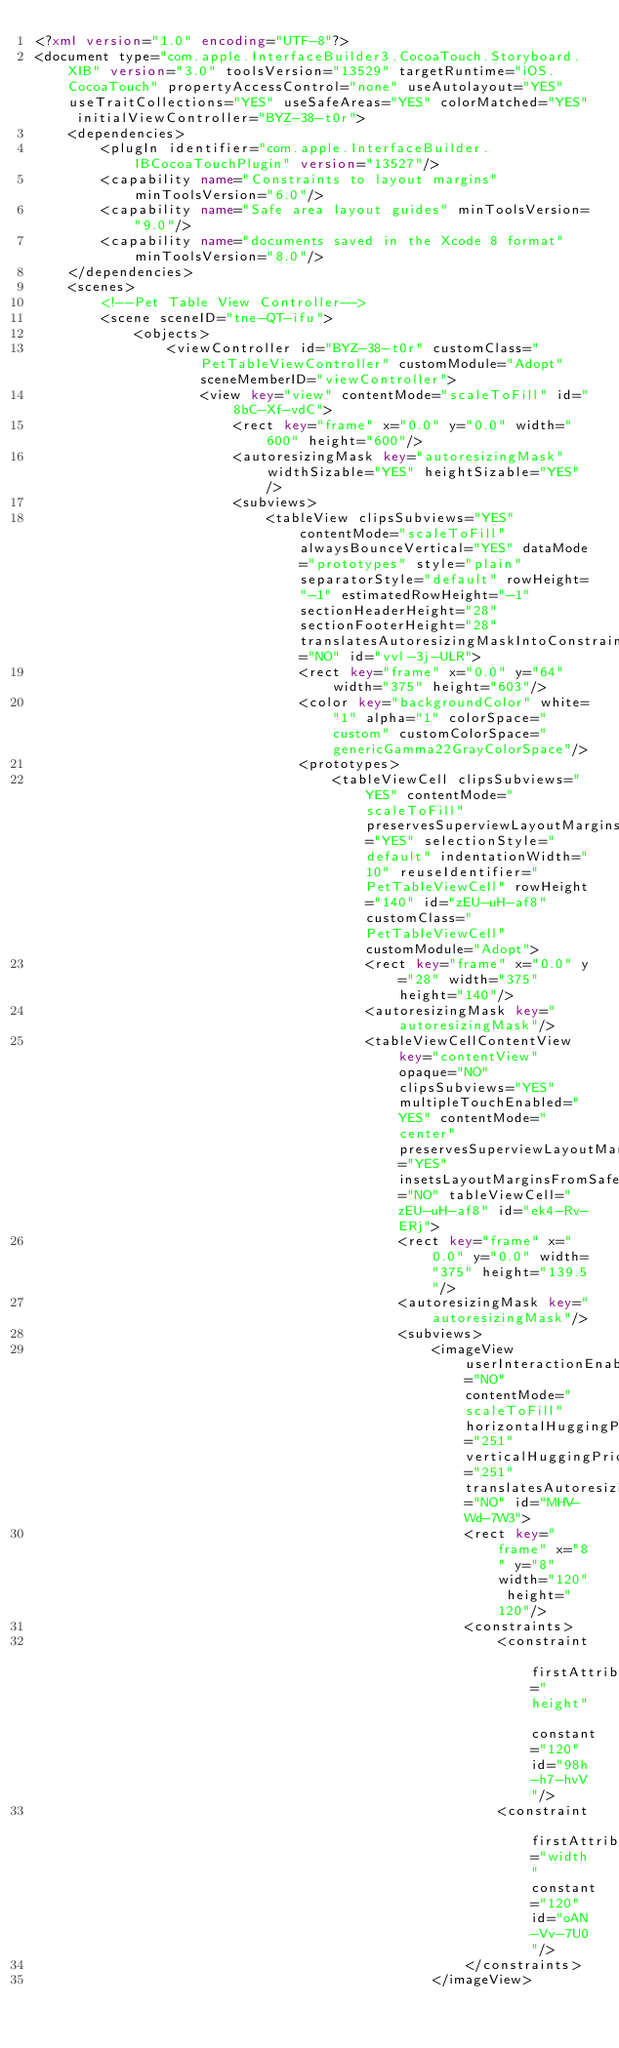<code> <loc_0><loc_0><loc_500><loc_500><_XML_><?xml version="1.0" encoding="UTF-8"?>
<document type="com.apple.InterfaceBuilder3.CocoaTouch.Storyboard.XIB" version="3.0" toolsVersion="13529" targetRuntime="iOS.CocoaTouch" propertyAccessControl="none" useAutolayout="YES" useTraitCollections="YES" useSafeAreas="YES" colorMatched="YES" initialViewController="BYZ-38-t0r">
    <dependencies>
        <plugIn identifier="com.apple.InterfaceBuilder.IBCocoaTouchPlugin" version="13527"/>
        <capability name="Constraints to layout margins" minToolsVersion="6.0"/>
        <capability name="Safe area layout guides" minToolsVersion="9.0"/>
        <capability name="documents saved in the Xcode 8 format" minToolsVersion="8.0"/>
    </dependencies>
    <scenes>
        <!--Pet Table View Controller-->
        <scene sceneID="tne-QT-ifu">
            <objects>
                <viewController id="BYZ-38-t0r" customClass="PetTableViewController" customModule="Adopt" sceneMemberID="viewController">
                    <view key="view" contentMode="scaleToFill" id="8bC-Xf-vdC">
                        <rect key="frame" x="0.0" y="0.0" width="600" height="600"/>
                        <autoresizingMask key="autoresizingMask" widthSizable="YES" heightSizable="YES"/>
                        <subviews>
                            <tableView clipsSubviews="YES" contentMode="scaleToFill" alwaysBounceVertical="YES" dataMode="prototypes" style="plain" separatorStyle="default" rowHeight="-1" estimatedRowHeight="-1" sectionHeaderHeight="28" sectionFooterHeight="28" translatesAutoresizingMaskIntoConstraints="NO" id="vvl-3j-ULR">
                                <rect key="frame" x="0.0" y="64" width="375" height="603"/>
                                <color key="backgroundColor" white="1" alpha="1" colorSpace="custom" customColorSpace="genericGamma22GrayColorSpace"/>
                                <prototypes>
                                    <tableViewCell clipsSubviews="YES" contentMode="scaleToFill" preservesSuperviewLayoutMargins="YES" selectionStyle="default" indentationWidth="10" reuseIdentifier="PetTableViewCell" rowHeight="140" id="zEU-uH-af8" customClass="PetTableViewCell" customModule="Adopt">
                                        <rect key="frame" x="0.0" y="28" width="375" height="140"/>
                                        <autoresizingMask key="autoresizingMask"/>
                                        <tableViewCellContentView key="contentView" opaque="NO" clipsSubviews="YES" multipleTouchEnabled="YES" contentMode="center" preservesSuperviewLayoutMargins="YES" insetsLayoutMarginsFromSafeArea="NO" tableViewCell="zEU-uH-af8" id="ek4-Rv-ERj">
                                            <rect key="frame" x="0.0" y="0.0" width="375" height="139.5"/>
                                            <autoresizingMask key="autoresizingMask"/>
                                            <subviews>
                                                <imageView userInteractionEnabled="NO" contentMode="scaleToFill" horizontalHuggingPriority="251" verticalHuggingPriority="251" translatesAutoresizingMaskIntoConstraints="NO" id="MHV-Wd-7W3">
                                                    <rect key="frame" x="8" y="8" width="120" height="120"/>
                                                    <constraints>
                                                        <constraint firstAttribute="height" constant="120" id="98h-h7-hvV"/>
                                                        <constraint firstAttribute="width" constant="120" id="oAN-Vv-7U0"/>
                                                    </constraints>
                                                </imageView></code> 